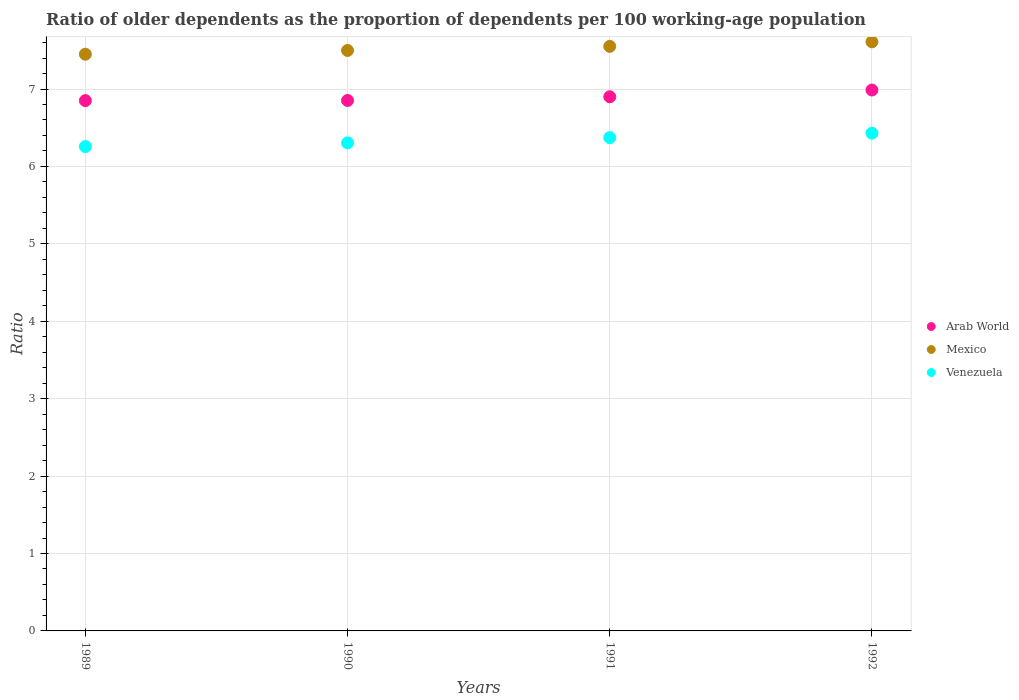How many different coloured dotlines are there?
Your answer should be compact. 3. What is the age dependency ratio(old) in Arab World in 1991?
Ensure brevity in your answer.  6.9. Across all years, what is the maximum age dependency ratio(old) in Venezuela?
Provide a short and direct response. 6.43. Across all years, what is the minimum age dependency ratio(old) in Arab World?
Ensure brevity in your answer.  6.85. In which year was the age dependency ratio(old) in Mexico maximum?
Give a very brief answer. 1992. In which year was the age dependency ratio(old) in Venezuela minimum?
Your answer should be very brief. 1989. What is the total age dependency ratio(old) in Mexico in the graph?
Make the answer very short. 30.11. What is the difference between the age dependency ratio(old) in Mexico in 1991 and that in 1992?
Your answer should be compact. -0.06. What is the difference between the age dependency ratio(old) in Venezuela in 1989 and the age dependency ratio(old) in Mexico in 1990?
Provide a succinct answer. -1.24. What is the average age dependency ratio(old) in Mexico per year?
Ensure brevity in your answer.  7.53. In the year 1992, what is the difference between the age dependency ratio(old) in Venezuela and age dependency ratio(old) in Arab World?
Your answer should be very brief. -0.56. In how many years, is the age dependency ratio(old) in Mexico greater than 4?
Provide a short and direct response. 4. What is the ratio of the age dependency ratio(old) in Venezuela in 1990 to that in 1992?
Your answer should be compact. 0.98. Is the age dependency ratio(old) in Mexico in 1989 less than that in 1992?
Your answer should be very brief. Yes. What is the difference between the highest and the second highest age dependency ratio(old) in Venezuela?
Make the answer very short. 0.06. What is the difference between the highest and the lowest age dependency ratio(old) in Mexico?
Offer a terse response. 0.16. Does the age dependency ratio(old) in Mexico monotonically increase over the years?
Make the answer very short. Yes. Is the age dependency ratio(old) in Arab World strictly less than the age dependency ratio(old) in Venezuela over the years?
Give a very brief answer. No. Where does the legend appear in the graph?
Make the answer very short. Center right. How are the legend labels stacked?
Your answer should be compact. Vertical. What is the title of the graph?
Offer a terse response. Ratio of older dependents as the proportion of dependents per 100 working-age population. Does "Bhutan" appear as one of the legend labels in the graph?
Give a very brief answer. No. What is the label or title of the X-axis?
Your response must be concise. Years. What is the label or title of the Y-axis?
Offer a very short reply. Ratio. What is the Ratio in Arab World in 1989?
Your answer should be very brief. 6.85. What is the Ratio of Mexico in 1989?
Offer a terse response. 7.45. What is the Ratio in Venezuela in 1989?
Your answer should be compact. 6.26. What is the Ratio in Arab World in 1990?
Provide a succinct answer. 6.85. What is the Ratio of Mexico in 1990?
Your response must be concise. 7.5. What is the Ratio in Venezuela in 1990?
Keep it short and to the point. 6.3. What is the Ratio in Arab World in 1991?
Offer a terse response. 6.9. What is the Ratio of Mexico in 1991?
Ensure brevity in your answer.  7.55. What is the Ratio of Venezuela in 1991?
Give a very brief answer. 6.37. What is the Ratio of Arab World in 1992?
Your answer should be very brief. 6.99. What is the Ratio in Mexico in 1992?
Provide a short and direct response. 7.61. What is the Ratio of Venezuela in 1992?
Ensure brevity in your answer.  6.43. Across all years, what is the maximum Ratio of Arab World?
Keep it short and to the point. 6.99. Across all years, what is the maximum Ratio of Mexico?
Your response must be concise. 7.61. Across all years, what is the maximum Ratio of Venezuela?
Give a very brief answer. 6.43. Across all years, what is the minimum Ratio in Arab World?
Keep it short and to the point. 6.85. Across all years, what is the minimum Ratio of Mexico?
Offer a very short reply. 7.45. Across all years, what is the minimum Ratio of Venezuela?
Your answer should be compact. 6.26. What is the total Ratio of Arab World in the graph?
Ensure brevity in your answer.  27.59. What is the total Ratio in Mexico in the graph?
Provide a short and direct response. 30.11. What is the total Ratio in Venezuela in the graph?
Your answer should be compact. 25.36. What is the difference between the Ratio of Arab World in 1989 and that in 1990?
Offer a very short reply. -0. What is the difference between the Ratio of Mexico in 1989 and that in 1990?
Offer a very short reply. -0.05. What is the difference between the Ratio of Venezuela in 1989 and that in 1990?
Ensure brevity in your answer.  -0.05. What is the difference between the Ratio of Arab World in 1989 and that in 1991?
Your answer should be compact. -0.05. What is the difference between the Ratio in Mexico in 1989 and that in 1991?
Provide a succinct answer. -0.1. What is the difference between the Ratio of Venezuela in 1989 and that in 1991?
Ensure brevity in your answer.  -0.12. What is the difference between the Ratio in Arab World in 1989 and that in 1992?
Ensure brevity in your answer.  -0.14. What is the difference between the Ratio in Mexico in 1989 and that in 1992?
Give a very brief answer. -0.16. What is the difference between the Ratio in Venezuela in 1989 and that in 1992?
Provide a succinct answer. -0.17. What is the difference between the Ratio in Arab World in 1990 and that in 1991?
Your answer should be compact. -0.05. What is the difference between the Ratio in Mexico in 1990 and that in 1991?
Your answer should be very brief. -0.05. What is the difference between the Ratio of Venezuela in 1990 and that in 1991?
Make the answer very short. -0.07. What is the difference between the Ratio in Arab World in 1990 and that in 1992?
Provide a succinct answer. -0.14. What is the difference between the Ratio in Mexico in 1990 and that in 1992?
Your answer should be very brief. -0.11. What is the difference between the Ratio in Venezuela in 1990 and that in 1992?
Your answer should be very brief. -0.13. What is the difference between the Ratio in Arab World in 1991 and that in 1992?
Give a very brief answer. -0.09. What is the difference between the Ratio of Mexico in 1991 and that in 1992?
Keep it short and to the point. -0.06. What is the difference between the Ratio in Venezuela in 1991 and that in 1992?
Make the answer very short. -0.06. What is the difference between the Ratio of Arab World in 1989 and the Ratio of Mexico in 1990?
Provide a succinct answer. -0.65. What is the difference between the Ratio in Arab World in 1989 and the Ratio in Venezuela in 1990?
Offer a very short reply. 0.55. What is the difference between the Ratio in Mexico in 1989 and the Ratio in Venezuela in 1990?
Your answer should be compact. 1.15. What is the difference between the Ratio in Arab World in 1989 and the Ratio in Mexico in 1991?
Offer a very short reply. -0.7. What is the difference between the Ratio of Arab World in 1989 and the Ratio of Venezuela in 1991?
Your answer should be very brief. 0.48. What is the difference between the Ratio of Mexico in 1989 and the Ratio of Venezuela in 1991?
Your answer should be very brief. 1.08. What is the difference between the Ratio in Arab World in 1989 and the Ratio in Mexico in 1992?
Keep it short and to the point. -0.76. What is the difference between the Ratio of Arab World in 1989 and the Ratio of Venezuela in 1992?
Keep it short and to the point. 0.42. What is the difference between the Ratio in Mexico in 1989 and the Ratio in Venezuela in 1992?
Make the answer very short. 1.02. What is the difference between the Ratio of Arab World in 1990 and the Ratio of Mexico in 1991?
Provide a succinct answer. -0.7. What is the difference between the Ratio in Arab World in 1990 and the Ratio in Venezuela in 1991?
Keep it short and to the point. 0.48. What is the difference between the Ratio of Mexico in 1990 and the Ratio of Venezuela in 1991?
Your response must be concise. 1.13. What is the difference between the Ratio in Arab World in 1990 and the Ratio in Mexico in 1992?
Your answer should be very brief. -0.76. What is the difference between the Ratio in Arab World in 1990 and the Ratio in Venezuela in 1992?
Provide a short and direct response. 0.42. What is the difference between the Ratio of Mexico in 1990 and the Ratio of Venezuela in 1992?
Make the answer very short. 1.07. What is the difference between the Ratio in Arab World in 1991 and the Ratio in Mexico in 1992?
Ensure brevity in your answer.  -0.71. What is the difference between the Ratio in Arab World in 1991 and the Ratio in Venezuela in 1992?
Provide a short and direct response. 0.47. What is the difference between the Ratio of Mexico in 1991 and the Ratio of Venezuela in 1992?
Provide a short and direct response. 1.12. What is the average Ratio in Arab World per year?
Make the answer very short. 6.9. What is the average Ratio of Mexico per year?
Give a very brief answer. 7.53. What is the average Ratio of Venezuela per year?
Your response must be concise. 6.34. In the year 1989, what is the difference between the Ratio in Arab World and Ratio in Mexico?
Your answer should be compact. -0.6. In the year 1989, what is the difference between the Ratio of Arab World and Ratio of Venezuela?
Offer a terse response. 0.59. In the year 1989, what is the difference between the Ratio of Mexico and Ratio of Venezuela?
Provide a succinct answer. 1.19. In the year 1990, what is the difference between the Ratio in Arab World and Ratio in Mexico?
Provide a succinct answer. -0.65. In the year 1990, what is the difference between the Ratio in Arab World and Ratio in Venezuela?
Keep it short and to the point. 0.55. In the year 1990, what is the difference between the Ratio of Mexico and Ratio of Venezuela?
Ensure brevity in your answer.  1.19. In the year 1991, what is the difference between the Ratio in Arab World and Ratio in Mexico?
Ensure brevity in your answer.  -0.65. In the year 1991, what is the difference between the Ratio of Arab World and Ratio of Venezuela?
Offer a very short reply. 0.53. In the year 1991, what is the difference between the Ratio in Mexico and Ratio in Venezuela?
Provide a succinct answer. 1.18. In the year 1992, what is the difference between the Ratio in Arab World and Ratio in Mexico?
Your answer should be compact. -0.62. In the year 1992, what is the difference between the Ratio of Arab World and Ratio of Venezuela?
Offer a very short reply. 0.56. In the year 1992, what is the difference between the Ratio in Mexico and Ratio in Venezuela?
Your response must be concise. 1.18. What is the ratio of the Ratio of Mexico in 1989 to that in 1990?
Provide a short and direct response. 0.99. What is the ratio of the Ratio of Venezuela in 1989 to that in 1990?
Ensure brevity in your answer.  0.99. What is the ratio of the Ratio of Mexico in 1989 to that in 1991?
Offer a terse response. 0.99. What is the ratio of the Ratio of Venezuela in 1989 to that in 1991?
Provide a short and direct response. 0.98. What is the ratio of the Ratio of Arab World in 1989 to that in 1992?
Ensure brevity in your answer.  0.98. What is the ratio of the Ratio in Mexico in 1989 to that in 1992?
Provide a short and direct response. 0.98. What is the ratio of the Ratio of Venezuela in 1989 to that in 1992?
Offer a terse response. 0.97. What is the ratio of the Ratio in Venezuela in 1990 to that in 1991?
Ensure brevity in your answer.  0.99. What is the ratio of the Ratio of Arab World in 1990 to that in 1992?
Keep it short and to the point. 0.98. What is the ratio of the Ratio in Venezuela in 1990 to that in 1992?
Keep it short and to the point. 0.98. What is the ratio of the Ratio in Arab World in 1991 to that in 1992?
Provide a succinct answer. 0.99. What is the ratio of the Ratio in Venezuela in 1991 to that in 1992?
Provide a succinct answer. 0.99. What is the difference between the highest and the second highest Ratio of Arab World?
Provide a succinct answer. 0.09. What is the difference between the highest and the second highest Ratio in Mexico?
Give a very brief answer. 0.06. What is the difference between the highest and the second highest Ratio of Venezuela?
Your response must be concise. 0.06. What is the difference between the highest and the lowest Ratio of Arab World?
Offer a terse response. 0.14. What is the difference between the highest and the lowest Ratio in Mexico?
Offer a very short reply. 0.16. What is the difference between the highest and the lowest Ratio of Venezuela?
Give a very brief answer. 0.17. 